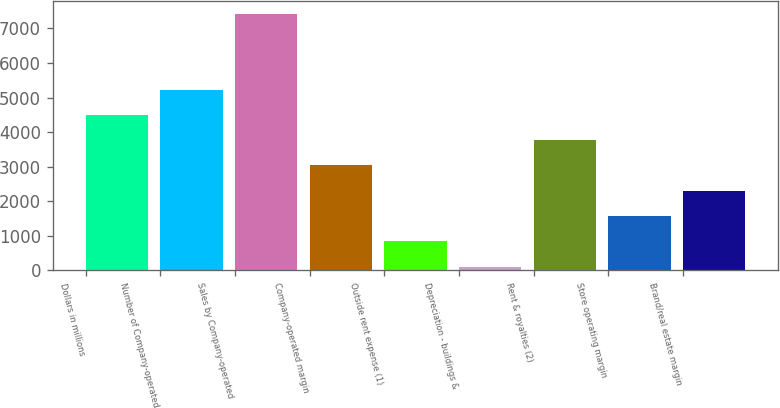Convert chart to OTSL. <chart><loc_0><loc_0><loc_500><loc_500><bar_chart><fcel>Dollars in millions<fcel>Number of Company-operated<fcel>Sales by Company-operated<fcel>Company-operated margin<fcel>Outside rent expense (1)<fcel>Depreciation - buildings &<fcel>Rent & royalties (2)<fcel>Store operating margin<fcel>Brand/real estate margin<nl><fcel>4498.4<fcel>5229.8<fcel>7424<fcel>3035.6<fcel>841.4<fcel>110<fcel>3767<fcel>1572.8<fcel>2304.2<nl></chart> 